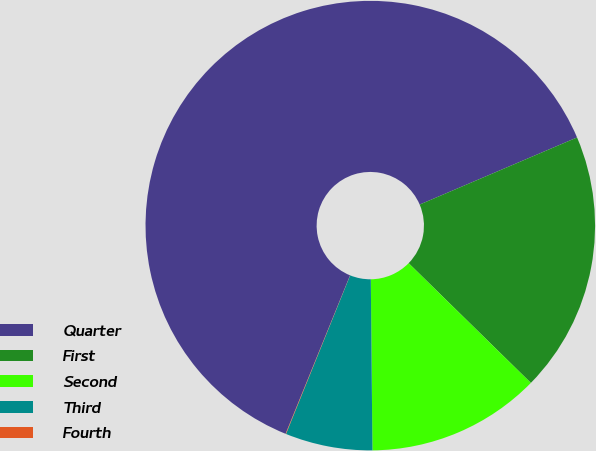<chart> <loc_0><loc_0><loc_500><loc_500><pie_chart><fcel>Quarter<fcel>First<fcel>Second<fcel>Third<fcel>Fourth<nl><fcel>62.43%<fcel>18.75%<fcel>12.51%<fcel>6.27%<fcel>0.03%<nl></chart> 